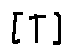<formula> <loc_0><loc_0><loc_500><loc_500>[ T ]</formula> 